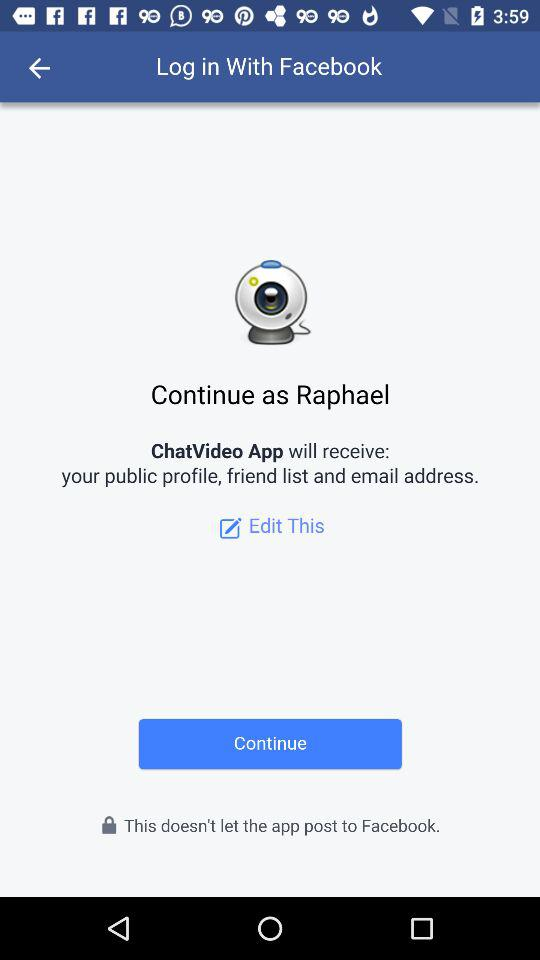What application is asking for permission? The application asking for permission is "ChatVideo App". 